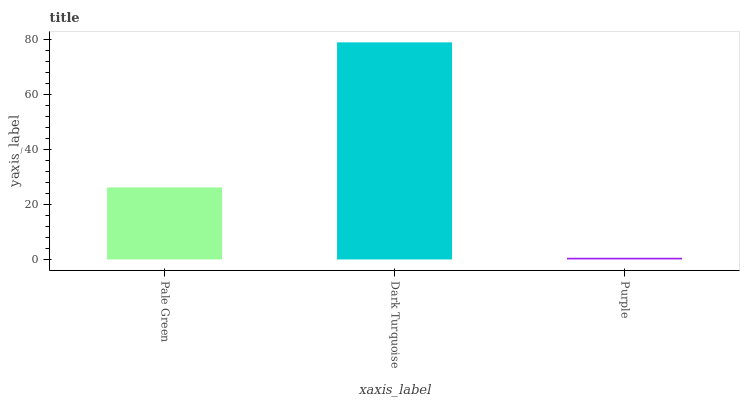Is Purple the minimum?
Answer yes or no. Yes. Is Dark Turquoise the maximum?
Answer yes or no. Yes. Is Dark Turquoise the minimum?
Answer yes or no. No. Is Purple the maximum?
Answer yes or no. No. Is Dark Turquoise greater than Purple?
Answer yes or no. Yes. Is Purple less than Dark Turquoise?
Answer yes or no. Yes. Is Purple greater than Dark Turquoise?
Answer yes or no. No. Is Dark Turquoise less than Purple?
Answer yes or no. No. Is Pale Green the high median?
Answer yes or no. Yes. Is Pale Green the low median?
Answer yes or no. Yes. Is Purple the high median?
Answer yes or no. No. Is Purple the low median?
Answer yes or no. No. 